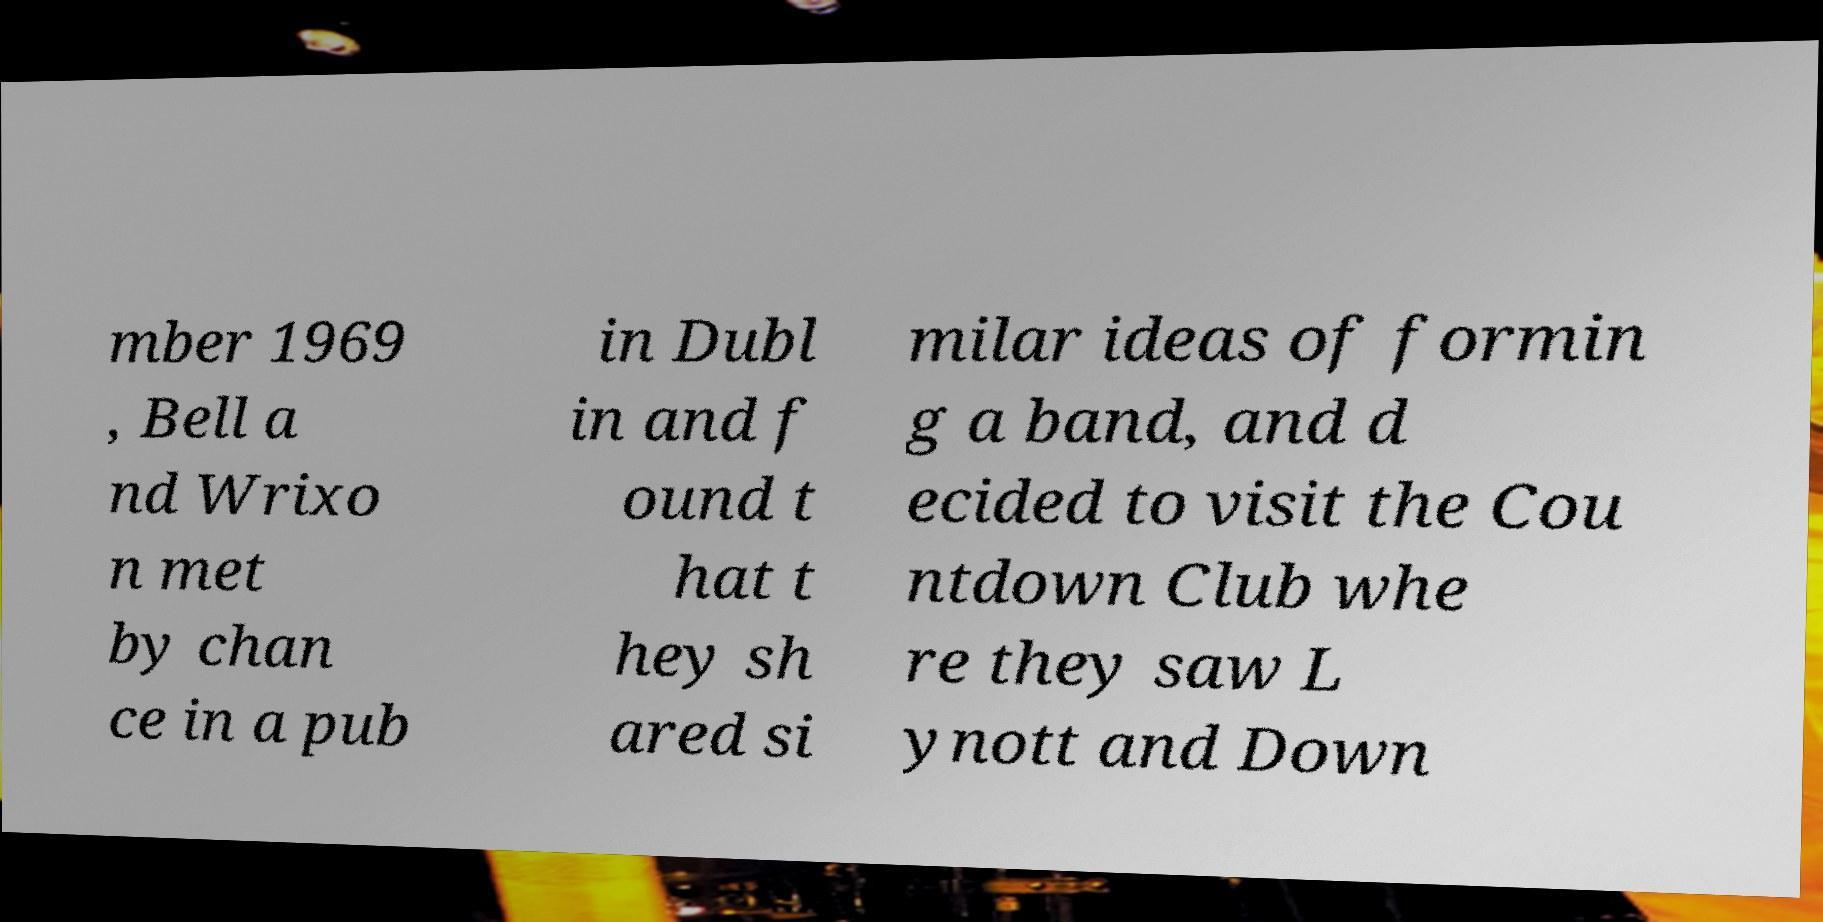Can you read and provide the text displayed in the image?This photo seems to have some interesting text. Can you extract and type it out for me? mber 1969 , Bell a nd Wrixo n met by chan ce in a pub in Dubl in and f ound t hat t hey sh ared si milar ideas of formin g a band, and d ecided to visit the Cou ntdown Club whe re they saw L ynott and Down 